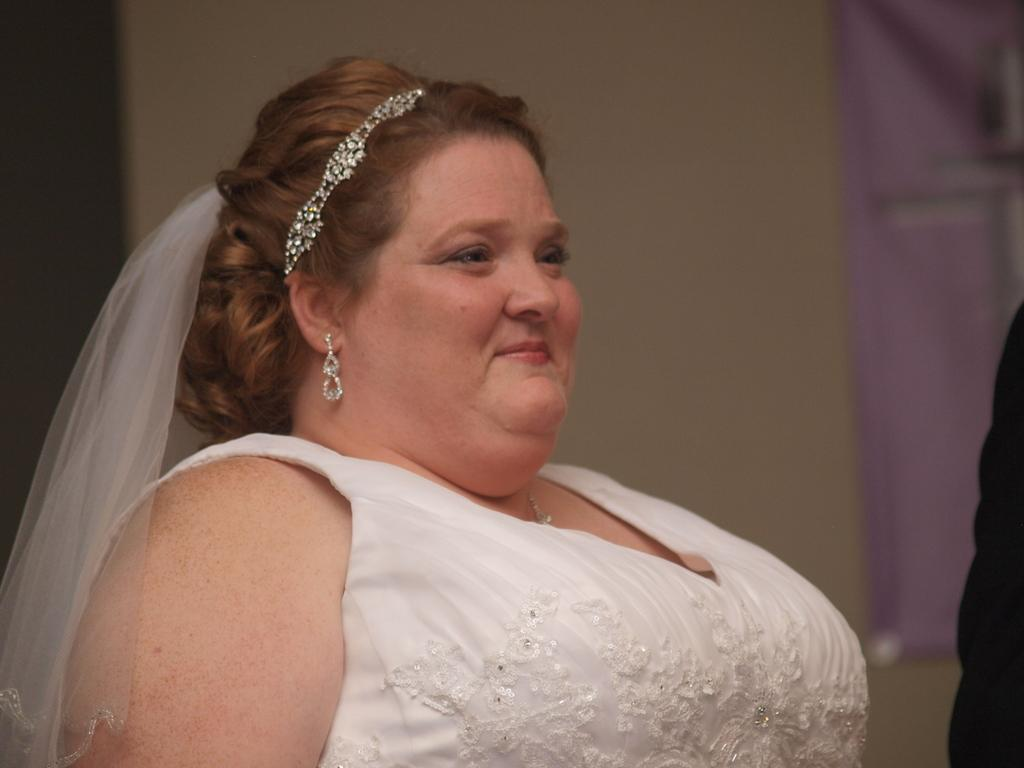What is the main subject of the picture? The main subject of the picture is a girl. What is the girl doing in the picture? The girl is standing in the picture. What is the girl's facial expression in the picture? The girl is smiling in the picture. What type of bread is the girl holding in the picture? There is no bread present in the picture; the girl is not holding anything. 